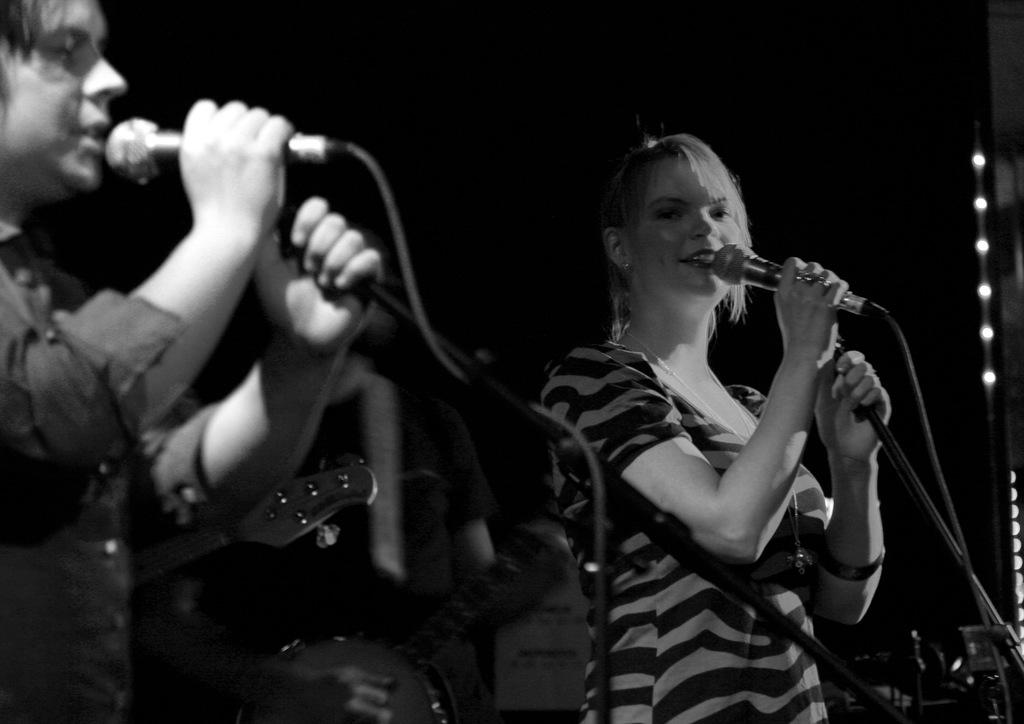Who are the people in the image? There is a man and a woman in the image. What are the man and woman holding in their hands? The man and woman are holding microphones in their hands. What might the man and woman be doing in the image? The man and woman are speaking something, which suggests they might be giving a speech or presentation. What type of paste can be seen in the garden in the image? There is no paste or garden present in the image; it features a man and a woman holding microphones. 